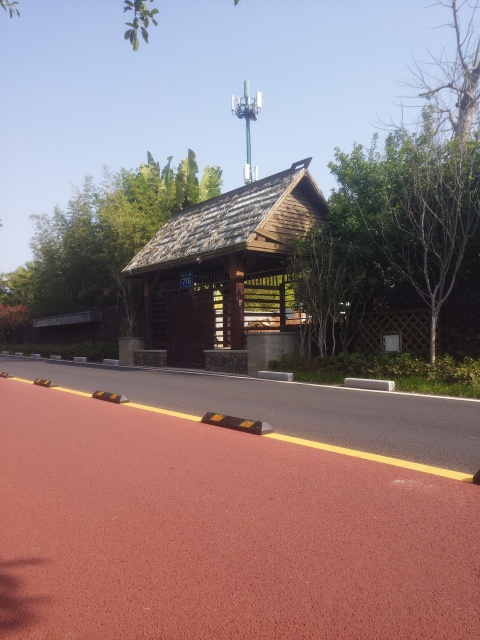How would you describe the lighting in this image? The lighting in this image is bright and natural, indicating that the photo was taken during the day under clear skies. The sun's position seems fairly high as shadows are short and objects are evenly illuminated, contributing to a clear visibility of the scene. 